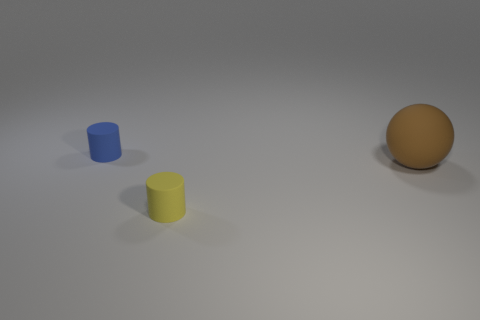Add 3 big brown things. How many objects exist? 6 Subtract all cylinders. How many objects are left? 1 Subtract all small blue metallic objects. Subtract all blue rubber cylinders. How many objects are left? 2 Add 2 blue rubber cylinders. How many blue rubber cylinders are left? 3 Add 3 small brown objects. How many small brown objects exist? 3 Subtract 0 gray balls. How many objects are left? 3 